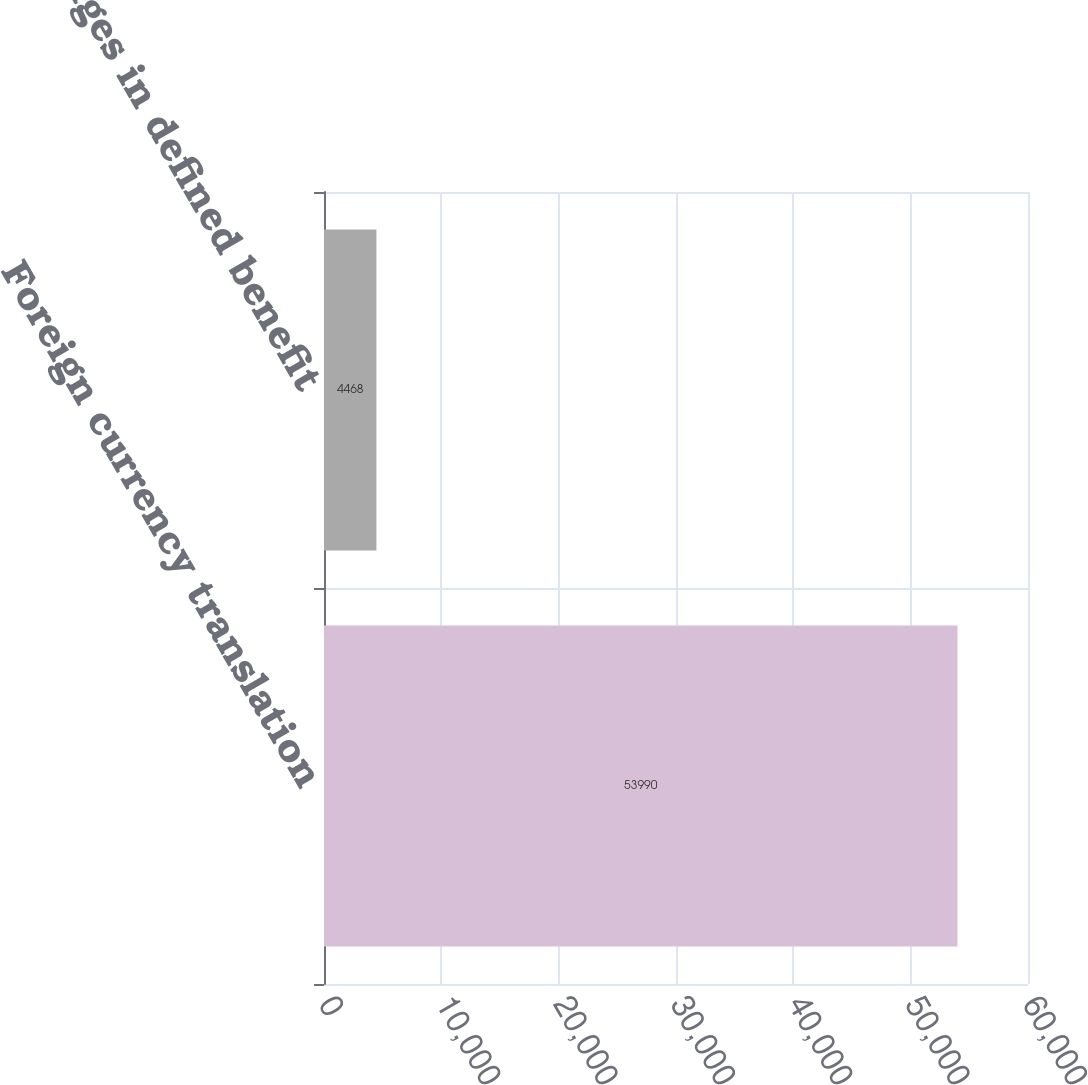Convert chart. <chart><loc_0><loc_0><loc_500><loc_500><bar_chart><fcel>Foreign currency translation<fcel>Changes in defined benefit<nl><fcel>53990<fcel>4468<nl></chart> 